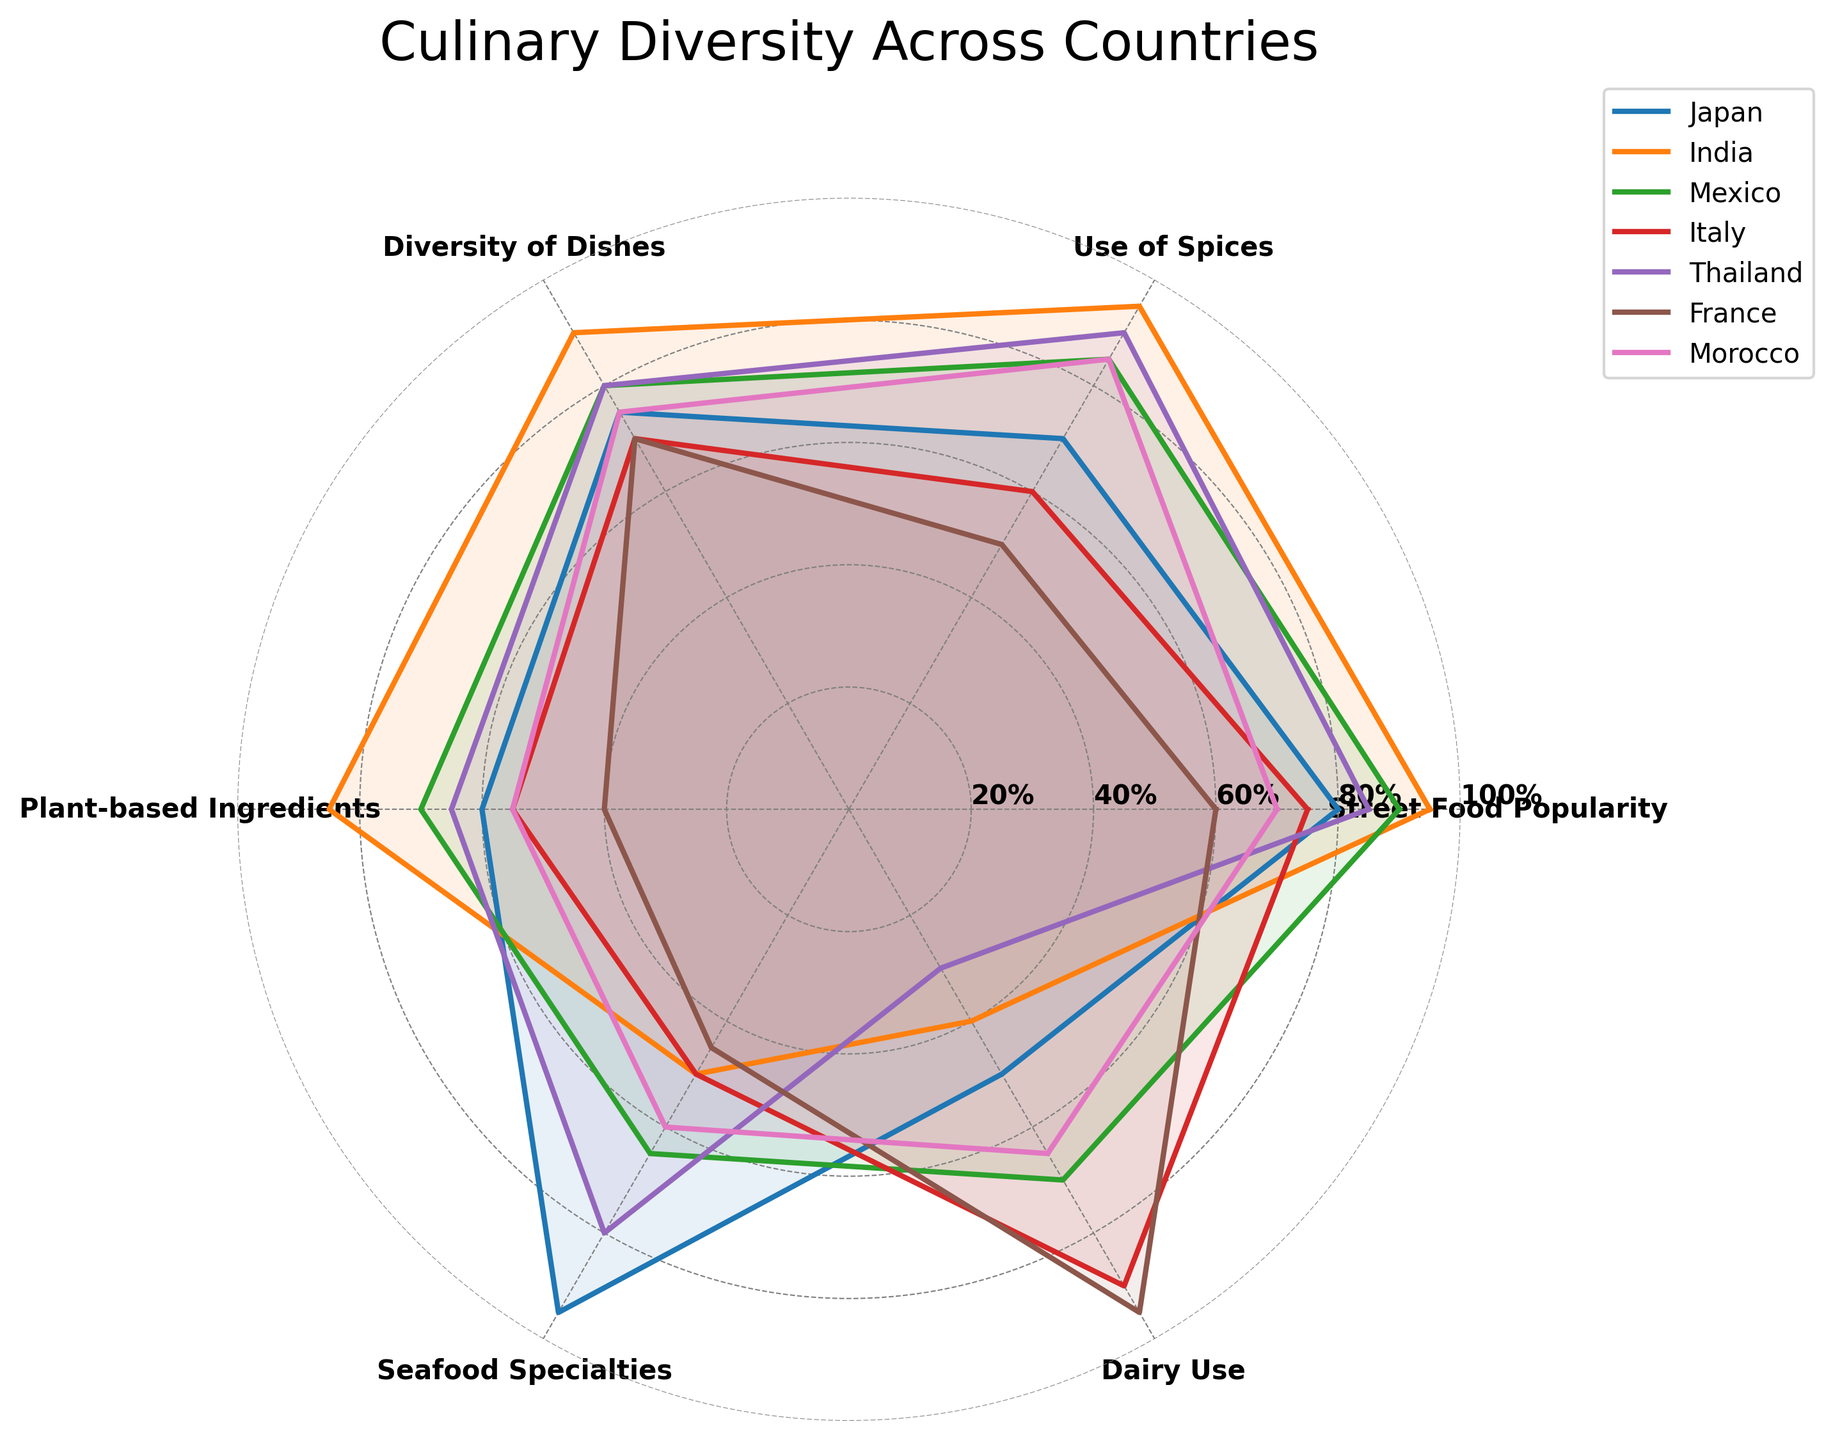What's the title of the radar chart? The title is usually placed at the top of the chart and labeled in a larger font size. In this case, it reads "Culinary Diversity Across Countries."
Answer: Culinary Diversity Across Countries Which country has the highest street food popularity? By examining the 'Street Food Popularity' axis, the highest value is found for India, which reaches up to 95%.
Answer: India Which two countries have similar values for the use of spices? Looking at the 'Use of Spices' axis, Japan and Morocco have values close to each other, around 70% and 85% respectively.
Answer: Japan and Morocco What is the range of values for plant-based ingredients among all countries? The 'Plant-based Ingredients' axis shows values from 40% (France) to 85% (India), hence the range can be calculated by subtracting the lowest value from the highest value (85 - 40).
Answer: 45 Which country features the most diverse culinary profile based on the combined radar area? A larger filled area generally indicates a higher diversity. India has the most extensive coverage in the plot, implying a high diversity in its culinary profile.
Answer: India Between Italy and France, which country uses more dairy? Observing the 'Dairy Use' axis, Italy has a value of 90%, whereas France has a value of 95%. Therefore, France uses more dairy products than Italy.
Answer: France Which country has the least emphasis on seafood specialties? By inspecting the 'Seafood Specialties' axis, Italy shows the lowest value of 50%.
Answer: Italy What's the average value of the use of spices across all countries? Sum the values of 'Use of Spices' for each country (70 + 95 + 85 + 60 + 90 + 50 + 85) to get 535. Since there are 7 countries, divide by 7 to find the average value (535 / 7).
Answer: 76.43 Comparing Japan and Thailand, which country has a higher diversity of dishes? Considering the 'Diversity of Dishes' axis, Japan has a value of 75%, whereas Thailand has a value of 80%. Thailand, therefore, has a higher diversity of dishes.
Answer: Thailand Which country has the smallest combined score for seafood specialties and plant-based ingredients? Adding up the values for 'Seafood Specialties' and 'Plant-based Ingredients' for each country, France has the smallest combined score (45 + 40 = 85).
Answer: France 